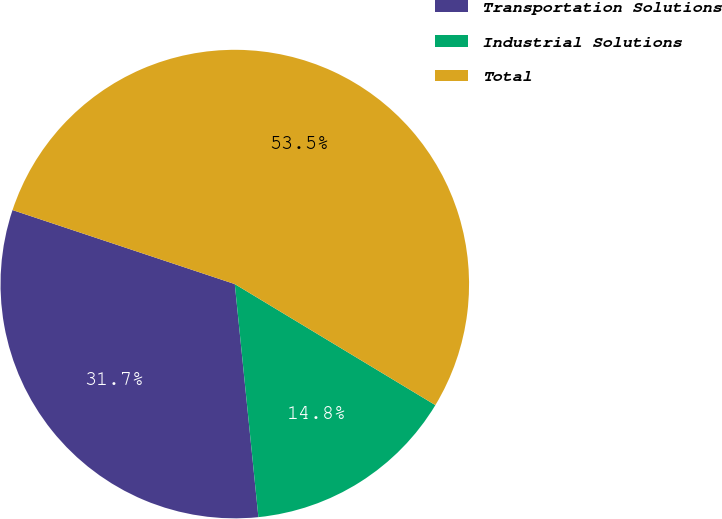<chart> <loc_0><loc_0><loc_500><loc_500><pie_chart><fcel>Transportation Solutions<fcel>Industrial Solutions<fcel>Total<nl><fcel>31.72%<fcel>14.75%<fcel>53.52%<nl></chart> 